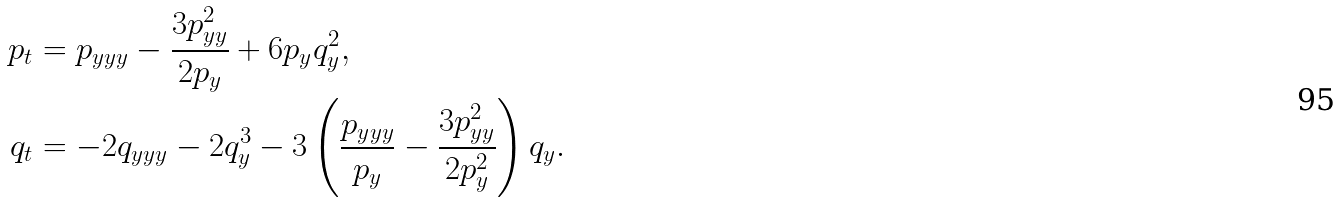Convert formula to latex. <formula><loc_0><loc_0><loc_500><loc_500>p _ { t } & = p _ { y y y } - \frac { 3 p _ { y y } ^ { 2 } } { 2 p _ { y } } + 6 p _ { y } q _ { y } ^ { 2 } , \\ q _ { t } & = - 2 q _ { y y y } - 2 q _ { y } ^ { 3 } - 3 \left ( \frac { p _ { y y y } } { p _ { y } } - \frac { 3 p _ { y y } ^ { 2 } } { 2 p _ { y } ^ { 2 } } \right ) q _ { y } .</formula> 